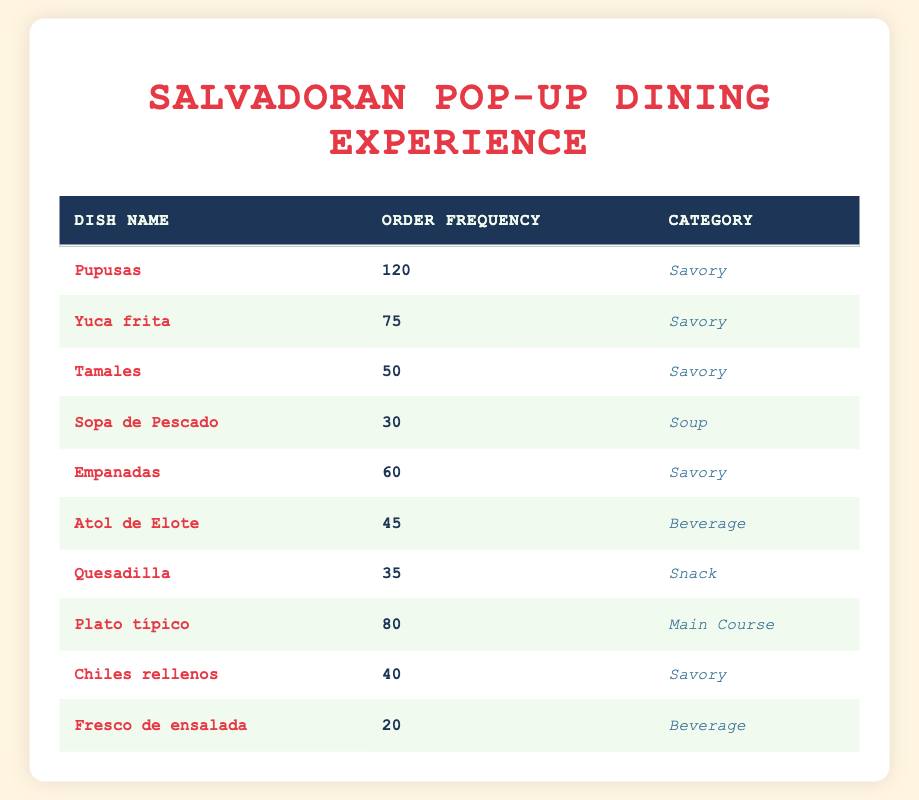What is the most frequently ordered dish? To find the most frequently ordered dish, we look for the highest order frequency value in the table. Pupusas has an order frequency of 120, which is greater than all other dishes listed.
Answer: Pupusas How many Savory dishes have more than 50 orders? The Savory dishes listed are Pupusas, Yuca frita, Tamales, Empanadas, and Chiles rellenos. Among these, Pupusas (120), Yuca frita (75), and Empanadas (60) have more than 50 orders. Therefore, there are three Savory dishes that meet this criterion.
Answer: 3 Is Sopa de Pescado the least ordered dish? To determine if Sopa de Pescado is the least ordered, we compare its order frequency of 30 to all other dishes. The next least ordered dish is Fresco de ensalada with 20 orders, which is less than 30. Hence, Sopa de Pescado is not the least ordered dish.
Answer: No What is the total order frequency for all the dishes listed? To find the total order frequency, we add the order frequencies of all the dishes: 120 + 75 + 50 + 30 + 60 + 45 + 35 + 80 + 40 + 20 = 510. Thus, the total order frequency for all dishes is 510.
Answer: 510 Which category has the highest total order frequency? We compute the total order frequencies for each category: Savory (120 + 75 + 50 + 60 + 40 = 345), Soup (30 = 30), Beverage (45 + 20 = 65), Snack (35 = 35), and Main Course (80 = 80). The highest total is for the Savory category with 345 orders.
Answer: Savory How many dishes belong to the Beverage category? In the table, the dishes in the Beverage category are Atol de Elote and Fresco de ensalada. Counting these gives us a total of two dishes in that category.
Answer: 2 What is the average order frequency of the Savory dishes? The Savory dishes and their frequencies are: Pupusas (120), Yuca frita (75), Tamales (50), Empanadas (60), and Chiles rellenos (40). We sum these values: 120 + 75 + 50 + 60 + 40 = 345. There are five Savory dishes, so we calculate the average: 345 divided by 5 equals 69.
Answer: 69 Which dish has the lowest order frequency in the Soup category? The only dish in the Soup category is Sopa de Pescado, which has an order frequency of 30. Since it is the only entry in that category, it automatically has the lowest frequency.
Answer: Sopa de Pescado Does any dish in the Snack category have more than 30 orders? The only dish in the Snack category is Quesadilla, which has an order frequency of 35. Since 35 is greater than 30, the answer is yes.
Answer: Yes 